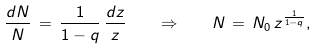Convert formula to latex. <formula><loc_0><loc_0><loc_500><loc_500>\frac { d N } { N } \, = \, \frac { 1 } { 1 - q } \, \frac { d z } { z } \quad \Rightarrow \quad N \, = \, N _ { 0 } \, z ^ { \frac { 1 } { 1 - q } } ,</formula> 